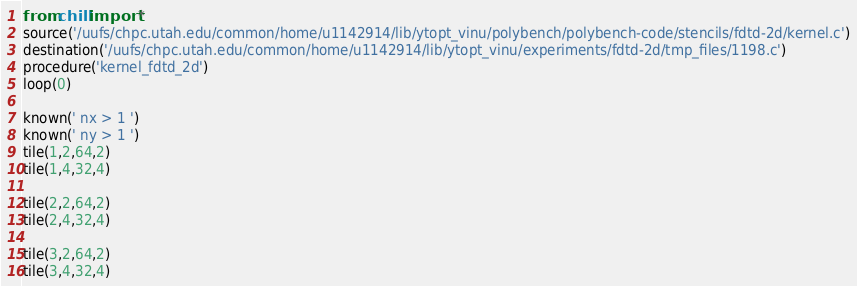<code> <loc_0><loc_0><loc_500><loc_500><_Python_>from chill import *
source('/uufs/chpc.utah.edu/common/home/u1142914/lib/ytopt_vinu/polybench/polybench-code/stencils/fdtd-2d/kernel.c')
destination('/uufs/chpc.utah.edu/common/home/u1142914/lib/ytopt_vinu/experiments/fdtd-2d/tmp_files/1198.c')
procedure('kernel_fdtd_2d')
loop(0)

known(' nx > 1 ')
known(' ny > 1 ')
tile(1,2,64,2)
tile(1,4,32,4)

tile(2,2,64,2)
tile(2,4,32,4)

tile(3,2,64,2)
tile(3,4,32,4)

</code> 